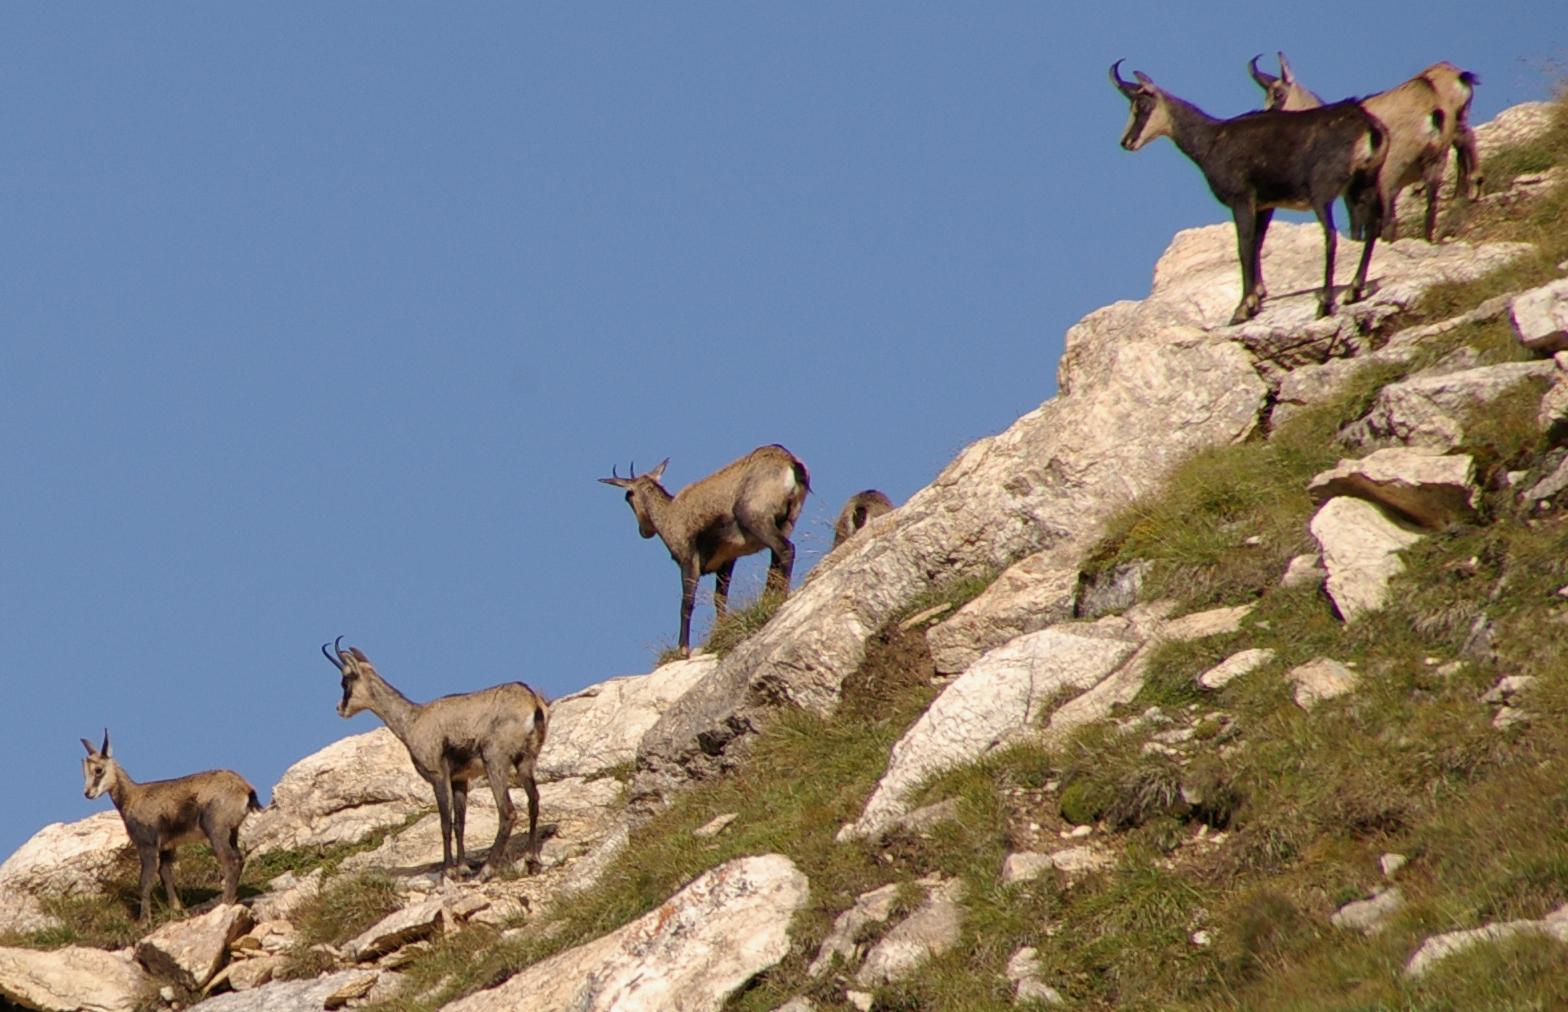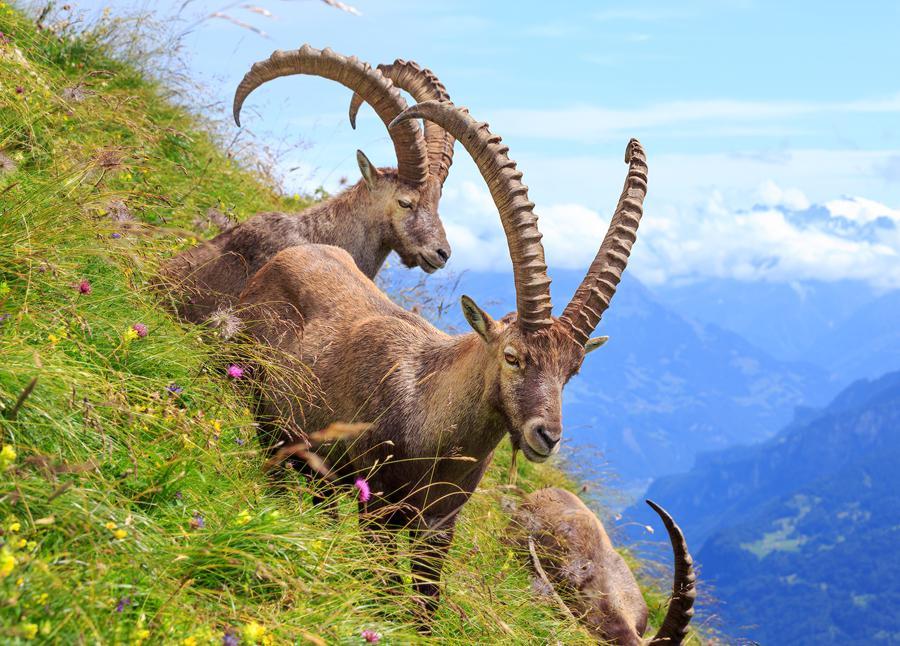The first image is the image on the left, the second image is the image on the right. For the images displayed, is the sentence "An image includes a rearing horned animal with front legs raised, facing off with another horned animal." factually correct? Answer yes or no. No. 